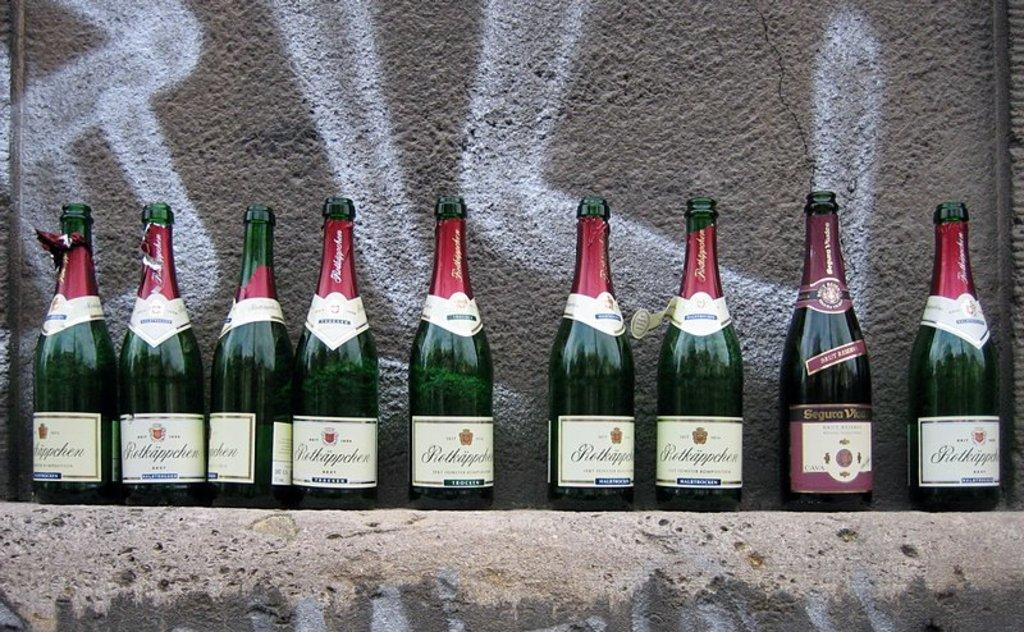What color are the bottles in the image? The bottles in the image are green. How are the bottles arranged in the image? The bottles are arranged in a sequence. What can be seen behind the bottles in the image? There is a wall behind the bottles. How many stitches are visible on the collar of the bottles in the image? There are no stitches or collars present on the bottles in the image, as they are bottles and not clothing items. 